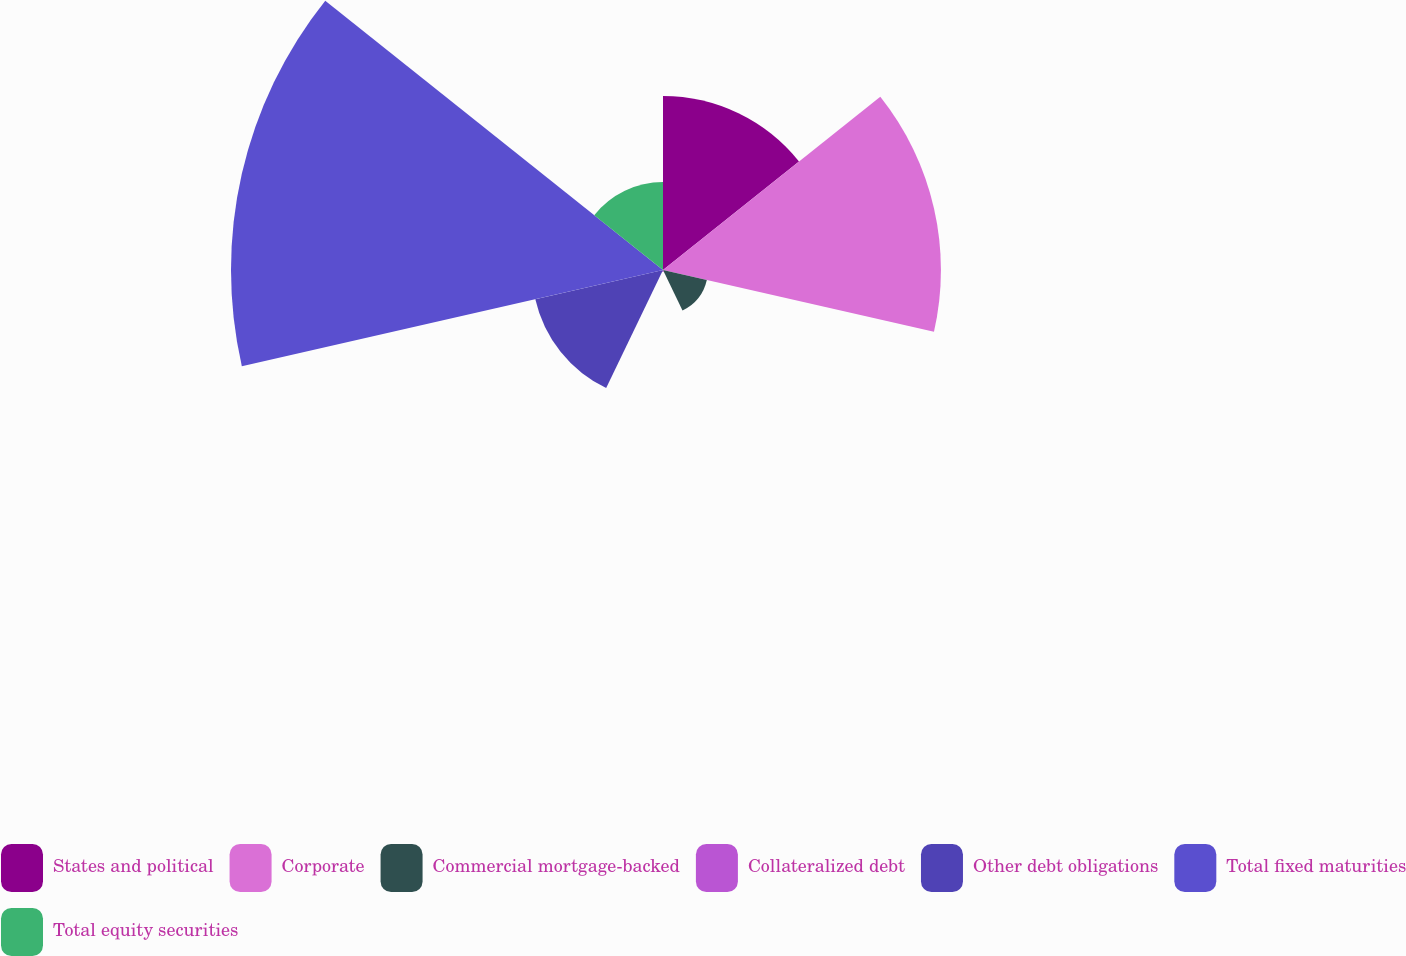Convert chart. <chart><loc_0><loc_0><loc_500><loc_500><pie_chart><fcel>States and political<fcel>Corporate<fcel>Commercial mortgage-backed<fcel>Collateralized debt<fcel>Other debt obligations<fcel>Total fixed maturities<fcel>Total equity securities<nl><fcel>15.13%<fcel>24.17%<fcel>3.91%<fcel>0.17%<fcel>11.39%<fcel>37.57%<fcel>7.65%<nl></chart> 